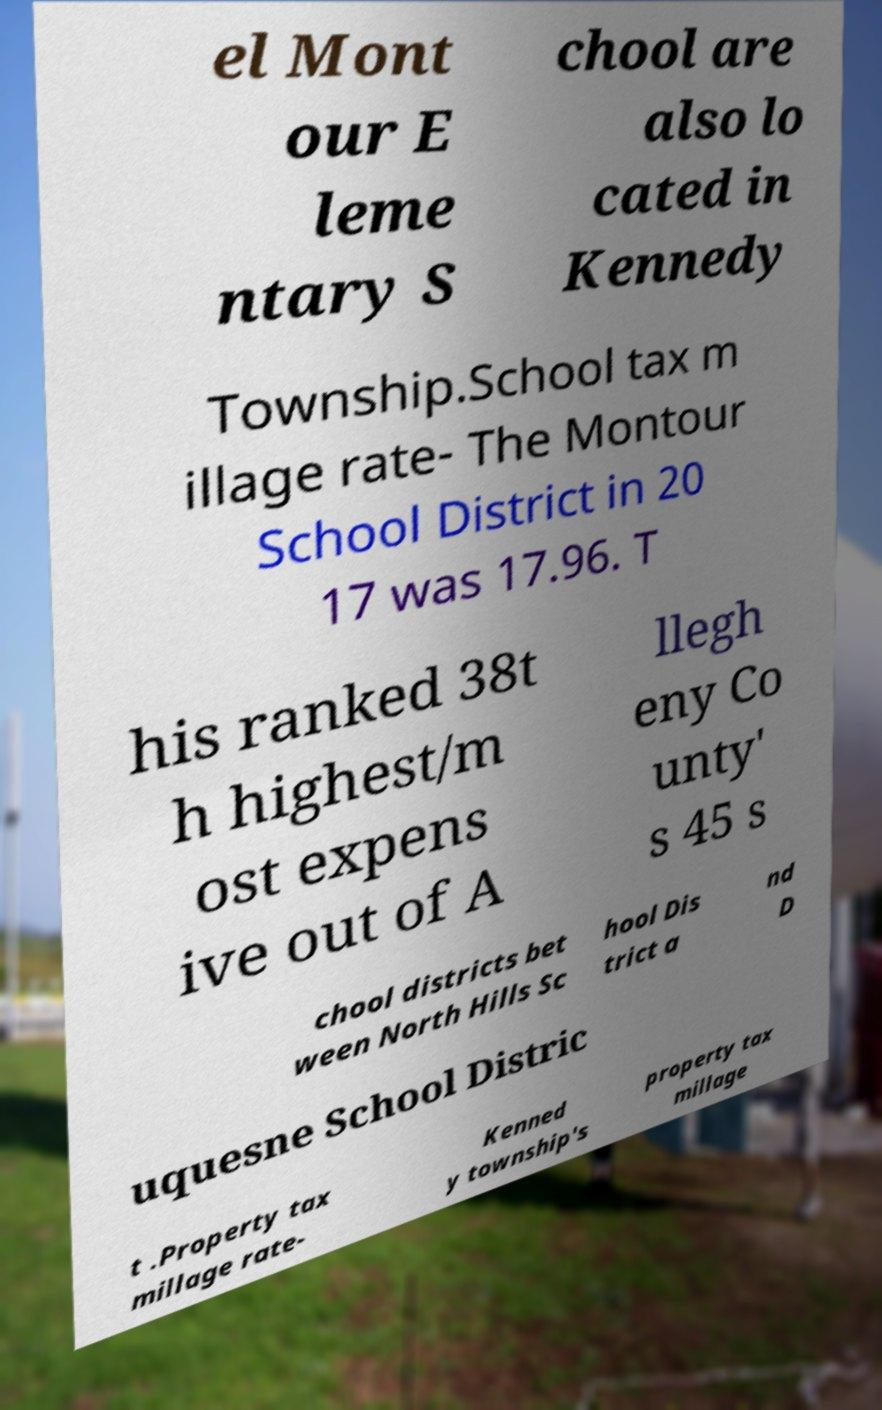Can you read and provide the text displayed in the image?This photo seems to have some interesting text. Can you extract and type it out for me? el Mont our E leme ntary S chool are also lo cated in Kennedy Township.School tax m illage rate- The Montour School District in 20 17 was 17.96. T his ranked 38t h highest/m ost expens ive out of A llegh eny Co unty' s 45 s chool districts bet ween North Hills Sc hool Dis trict a nd D uquesne School Distric t .Property tax millage rate- Kenned y township's property tax millage 